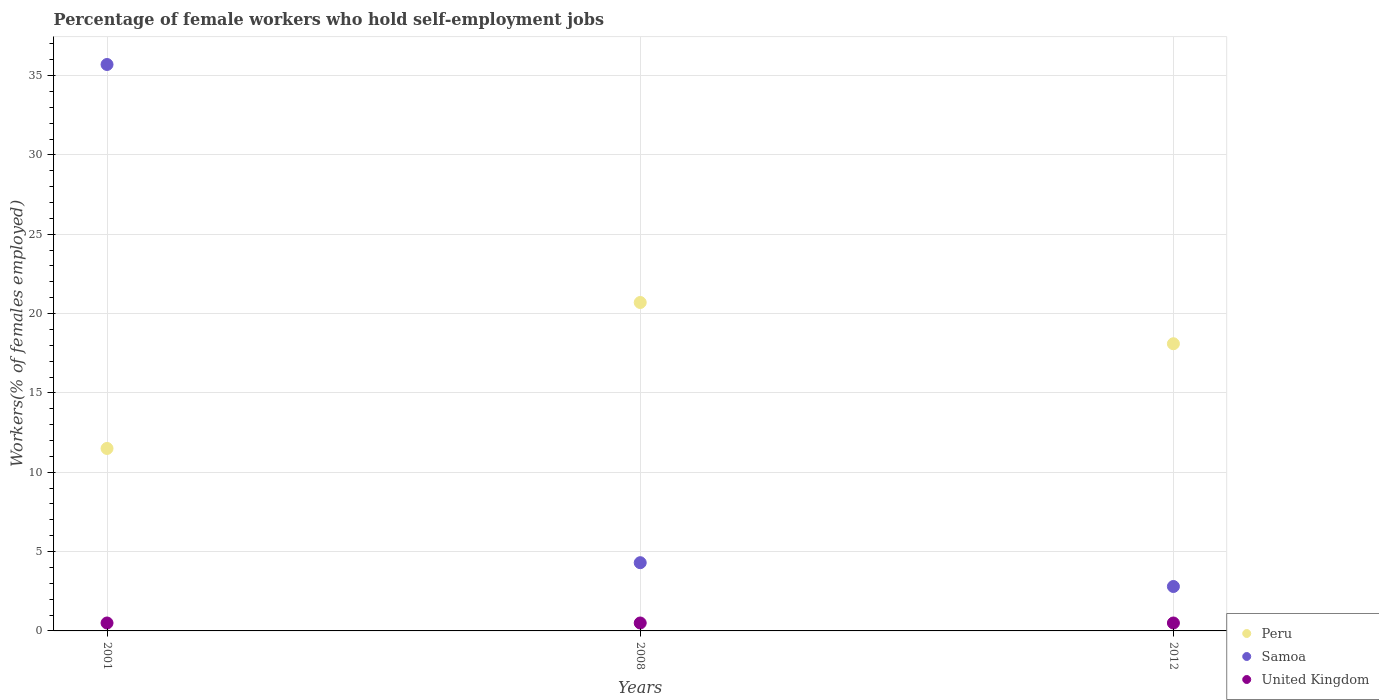How many different coloured dotlines are there?
Offer a terse response. 3. Is the number of dotlines equal to the number of legend labels?
Provide a short and direct response. Yes. Across all years, what is the maximum percentage of self-employed female workers in Samoa?
Keep it short and to the point. 35.7. In which year was the percentage of self-employed female workers in Peru maximum?
Provide a short and direct response. 2008. What is the total percentage of self-employed female workers in Samoa in the graph?
Make the answer very short. 42.8. What is the difference between the percentage of self-employed female workers in Peru in 2001 and that in 2008?
Offer a terse response. -9.2. What is the difference between the percentage of self-employed female workers in Peru in 2008 and the percentage of self-employed female workers in United Kingdom in 2012?
Ensure brevity in your answer.  20.2. What is the average percentage of self-employed female workers in Peru per year?
Your answer should be compact. 16.77. In the year 2001, what is the difference between the percentage of self-employed female workers in United Kingdom and percentage of self-employed female workers in Samoa?
Your answer should be compact. -35.2. In how many years, is the percentage of self-employed female workers in Samoa greater than 36 %?
Give a very brief answer. 0. What is the ratio of the percentage of self-employed female workers in Peru in 2008 to that in 2012?
Make the answer very short. 1.14. What is the difference between the highest and the second highest percentage of self-employed female workers in Samoa?
Offer a very short reply. 31.4. What is the difference between the highest and the lowest percentage of self-employed female workers in Peru?
Make the answer very short. 9.2. Is the sum of the percentage of self-employed female workers in United Kingdom in 2001 and 2012 greater than the maximum percentage of self-employed female workers in Peru across all years?
Offer a very short reply. No. Is it the case that in every year, the sum of the percentage of self-employed female workers in Samoa and percentage of self-employed female workers in United Kingdom  is greater than the percentage of self-employed female workers in Peru?
Provide a succinct answer. No. Is the percentage of self-employed female workers in United Kingdom strictly greater than the percentage of self-employed female workers in Peru over the years?
Provide a succinct answer. No. How many dotlines are there?
Your answer should be very brief. 3. How many years are there in the graph?
Your answer should be very brief. 3. What is the difference between two consecutive major ticks on the Y-axis?
Keep it short and to the point. 5. Does the graph contain grids?
Offer a very short reply. Yes. How many legend labels are there?
Offer a very short reply. 3. How are the legend labels stacked?
Give a very brief answer. Vertical. What is the title of the graph?
Make the answer very short. Percentage of female workers who hold self-employment jobs. Does "Paraguay" appear as one of the legend labels in the graph?
Your answer should be very brief. No. What is the label or title of the Y-axis?
Make the answer very short. Workers(% of females employed). What is the Workers(% of females employed) of Peru in 2001?
Offer a very short reply. 11.5. What is the Workers(% of females employed) in Samoa in 2001?
Provide a succinct answer. 35.7. What is the Workers(% of females employed) of United Kingdom in 2001?
Ensure brevity in your answer.  0.5. What is the Workers(% of females employed) of Peru in 2008?
Give a very brief answer. 20.7. What is the Workers(% of females employed) in Samoa in 2008?
Offer a very short reply. 4.3. What is the Workers(% of females employed) in United Kingdom in 2008?
Ensure brevity in your answer.  0.5. What is the Workers(% of females employed) in Peru in 2012?
Provide a short and direct response. 18.1. What is the Workers(% of females employed) in Samoa in 2012?
Your answer should be compact. 2.8. Across all years, what is the maximum Workers(% of females employed) of Peru?
Ensure brevity in your answer.  20.7. Across all years, what is the maximum Workers(% of females employed) in Samoa?
Your answer should be compact. 35.7. Across all years, what is the minimum Workers(% of females employed) of Samoa?
Ensure brevity in your answer.  2.8. Across all years, what is the minimum Workers(% of females employed) of United Kingdom?
Offer a very short reply. 0.5. What is the total Workers(% of females employed) in Peru in the graph?
Ensure brevity in your answer.  50.3. What is the total Workers(% of females employed) of Samoa in the graph?
Provide a succinct answer. 42.8. What is the difference between the Workers(% of females employed) in Samoa in 2001 and that in 2008?
Your response must be concise. 31.4. What is the difference between the Workers(% of females employed) in Peru in 2001 and that in 2012?
Your answer should be compact. -6.6. What is the difference between the Workers(% of females employed) in Samoa in 2001 and that in 2012?
Make the answer very short. 32.9. What is the difference between the Workers(% of females employed) of Peru in 2008 and that in 2012?
Provide a succinct answer. 2.6. What is the difference between the Workers(% of females employed) of United Kingdom in 2008 and that in 2012?
Offer a very short reply. 0. What is the difference between the Workers(% of females employed) of Samoa in 2001 and the Workers(% of females employed) of United Kingdom in 2008?
Offer a terse response. 35.2. What is the difference between the Workers(% of females employed) in Peru in 2001 and the Workers(% of females employed) in Samoa in 2012?
Keep it short and to the point. 8.7. What is the difference between the Workers(% of females employed) of Peru in 2001 and the Workers(% of females employed) of United Kingdom in 2012?
Your answer should be compact. 11. What is the difference between the Workers(% of females employed) of Samoa in 2001 and the Workers(% of females employed) of United Kingdom in 2012?
Your answer should be compact. 35.2. What is the difference between the Workers(% of females employed) in Peru in 2008 and the Workers(% of females employed) in United Kingdom in 2012?
Your answer should be very brief. 20.2. What is the difference between the Workers(% of females employed) in Samoa in 2008 and the Workers(% of females employed) in United Kingdom in 2012?
Your answer should be compact. 3.8. What is the average Workers(% of females employed) in Peru per year?
Give a very brief answer. 16.77. What is the average Workers(% of females employed) of Samoa per year?
Keep it short and to the point. 14.27. In the year 2001, what is the difference between the Workers(% of females employed) in Peru and Workers(% of females employed) in Samoa?
Provide a short and direct response. -24.2. In the year 2001, what is the difference between the Workers(% of females employed) of Samoa and Workers(% of females employed) of United Kingdom?
Your response must be concise. 35.2. In the year 2008, what is the difference between the Workers(% of females employed) of Peru and Workers(% of females employed) of United Kingdom?
Give a very brief answer. 20.2. In the year 2008, what is the difference between the Workers(% of females employed) in Samoa and Workers(% of females employed) in United Kingdom?
Your answer should be compact. 3.8. In the year 2012, what is the difference between the Workers(% of females employed) of Samoa and Workers(% of females employed) of United Kingdom?
Give a very brief answer. 2.3. What is the ratio of the Workers(% of females employed) in Peru in 2001 to that in 2008?
Your answer should be compact. 0.56. What is the ratio of the Workers(% of females employed) in Samoa in 2001 to that in 2008?
Provide a short and direct response. 8.3. What is the ratio of the Workers(% of females employed) in Peru in 2001 to that in 2012?
Provide a succinct answer. 0.64. What is the ratio of the Workers(% of females employed) in Samoa in 2001 to that in 2012?
Offer a very short reply. 12.75. What is the ratio of the Workers(% of females employed) in United Kingdom in 2001 to that in 2012?
Keep it short and to the point. 1. What is the ratio of the Workers(% of females employed) in Peru in 2008 to that in 2012?
Offer a terse response. 1.14. What is the ratio of the Workers(% of females employed) in Samoa in 2008 to that in 2012?
Make the answer very short. 1.54. What is the difference between the highest and the second highest Workers(% of females employed) in Samoa?
Ensure brevity in your answer.  31.4. What is the difference between the highest and the second highest Workers(% of females employed) in United Kingdom?
Your answer should be compact. 0. What is the difference between the highest and the lowest Workers(% of females employed) in Samoa?
Keep it short and to the point. 32.9. What is the difference between the highest and the lowest Workers(% of females employed) in United Kingdom?
Your answer should be very brief. 0. 